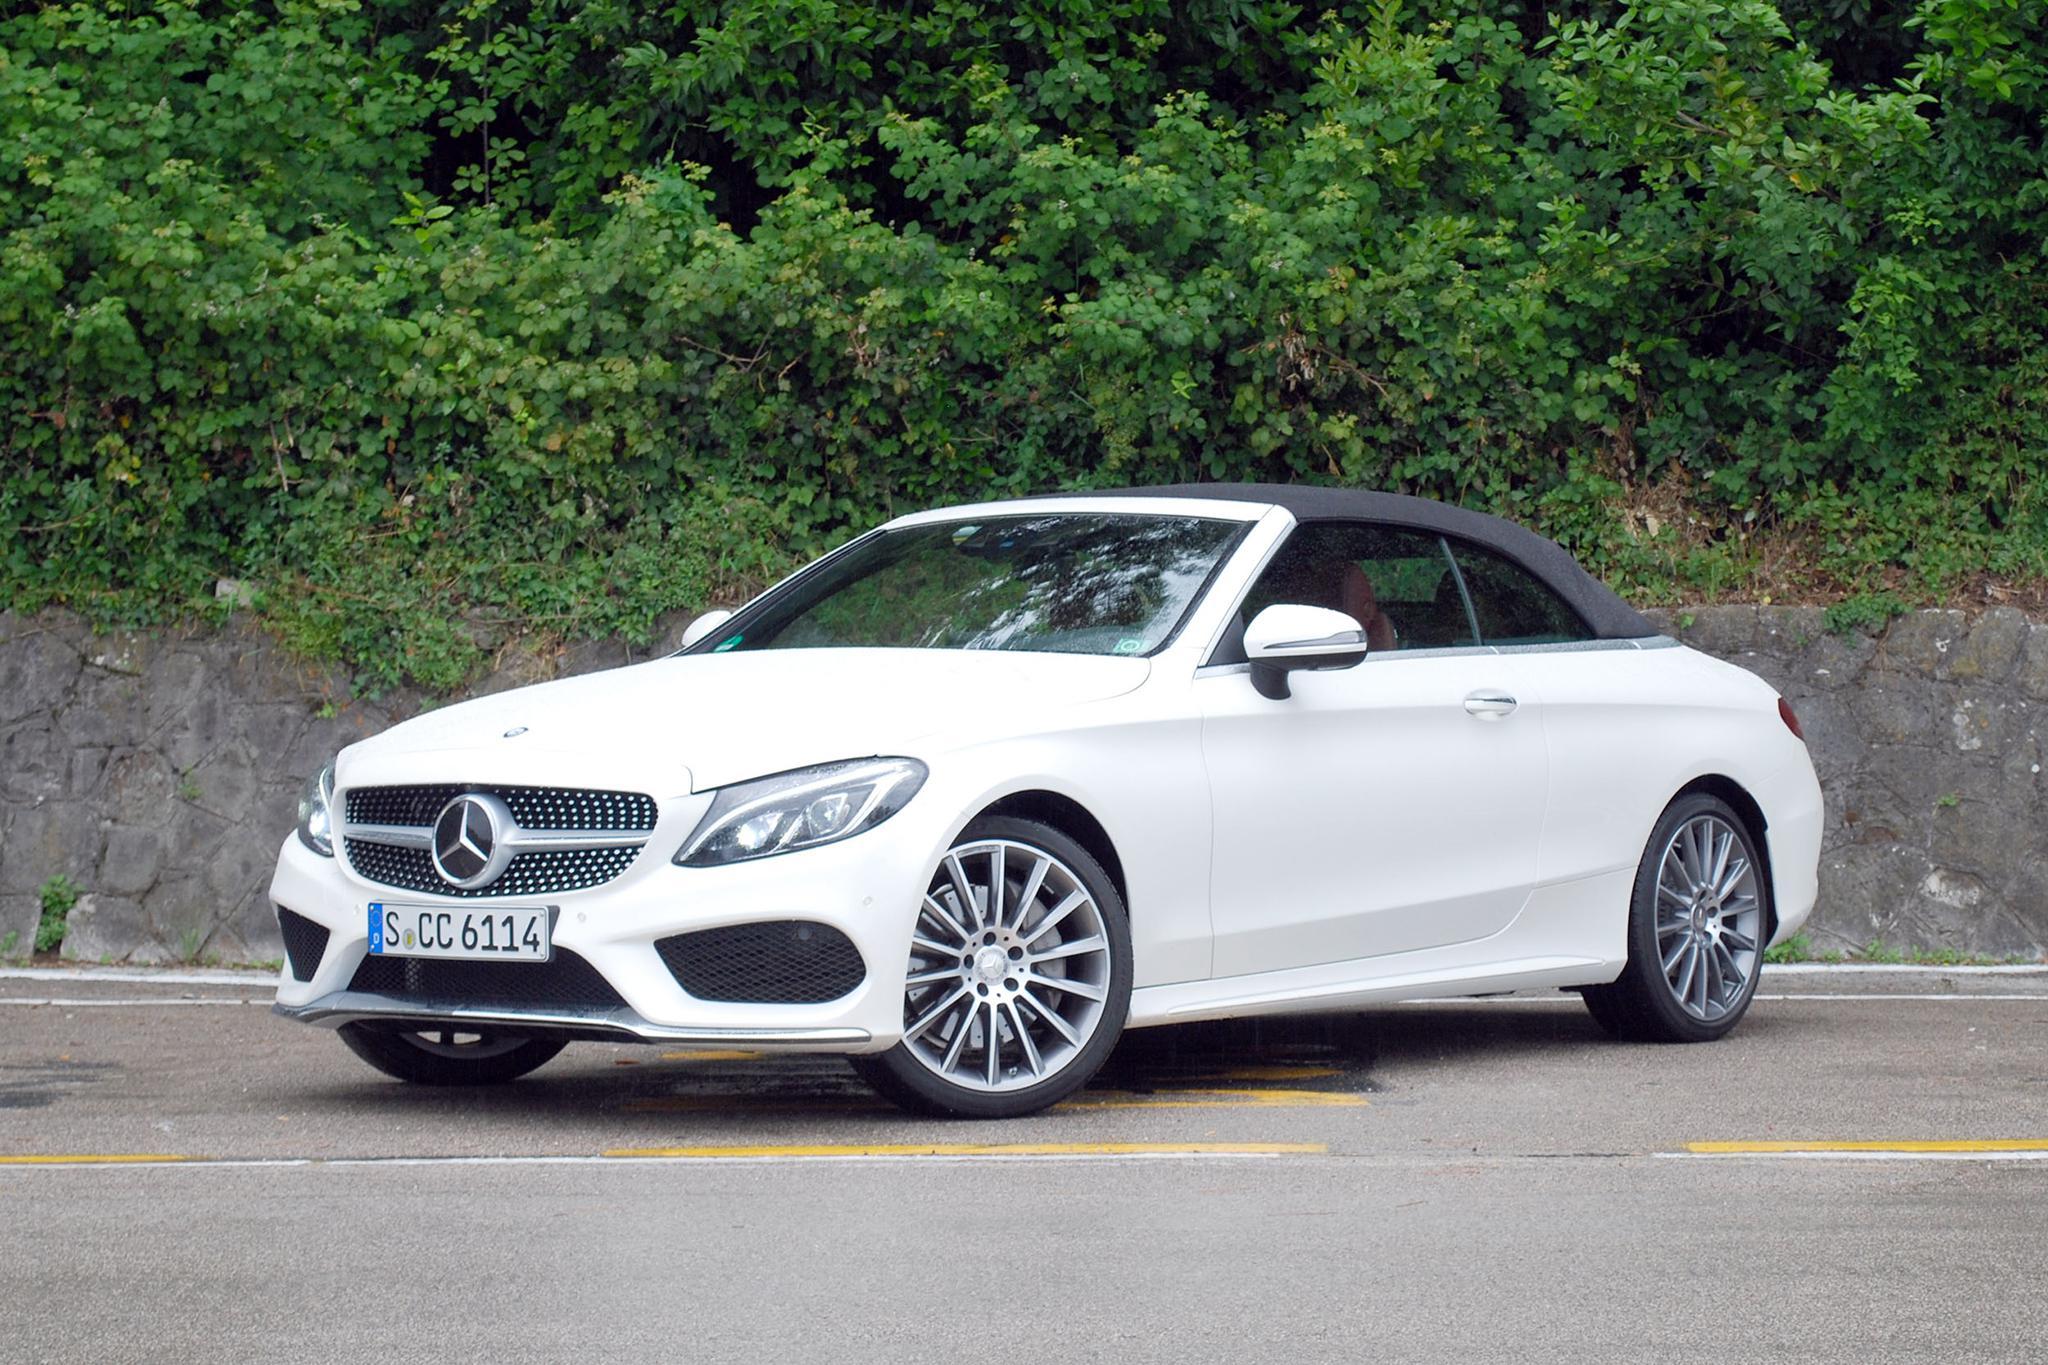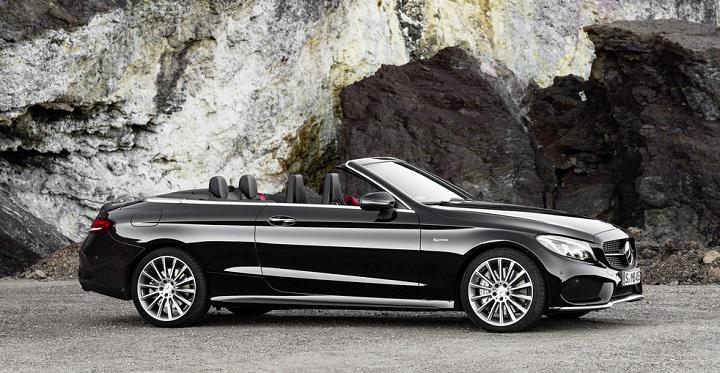The first image is the image on the left, the second image is the image on the right. Examine the images to the left and right. Is the description "In one of the images there is a convertible parked outside with a building visible in the background." accurate? Answer yes or no. No. The first image is the image on the left, the second image is the image on the right. For the images displayed, is the sentence "One image shows a white convertible with its top covered." factually correct? Answer yes or no. Yes. 